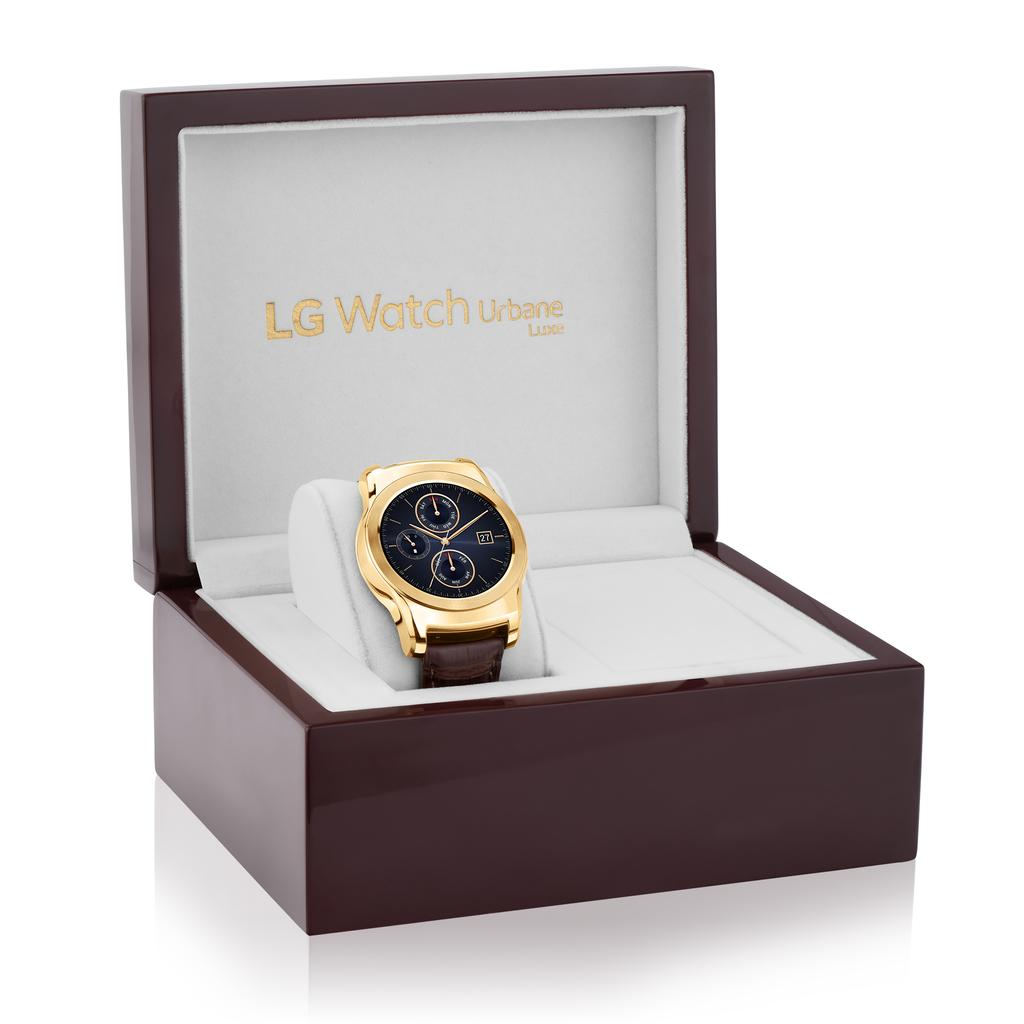<image>
Write a terse but informative summary of the picture. A luxury watch in a brown box with the logo LG Watch Urbane. 